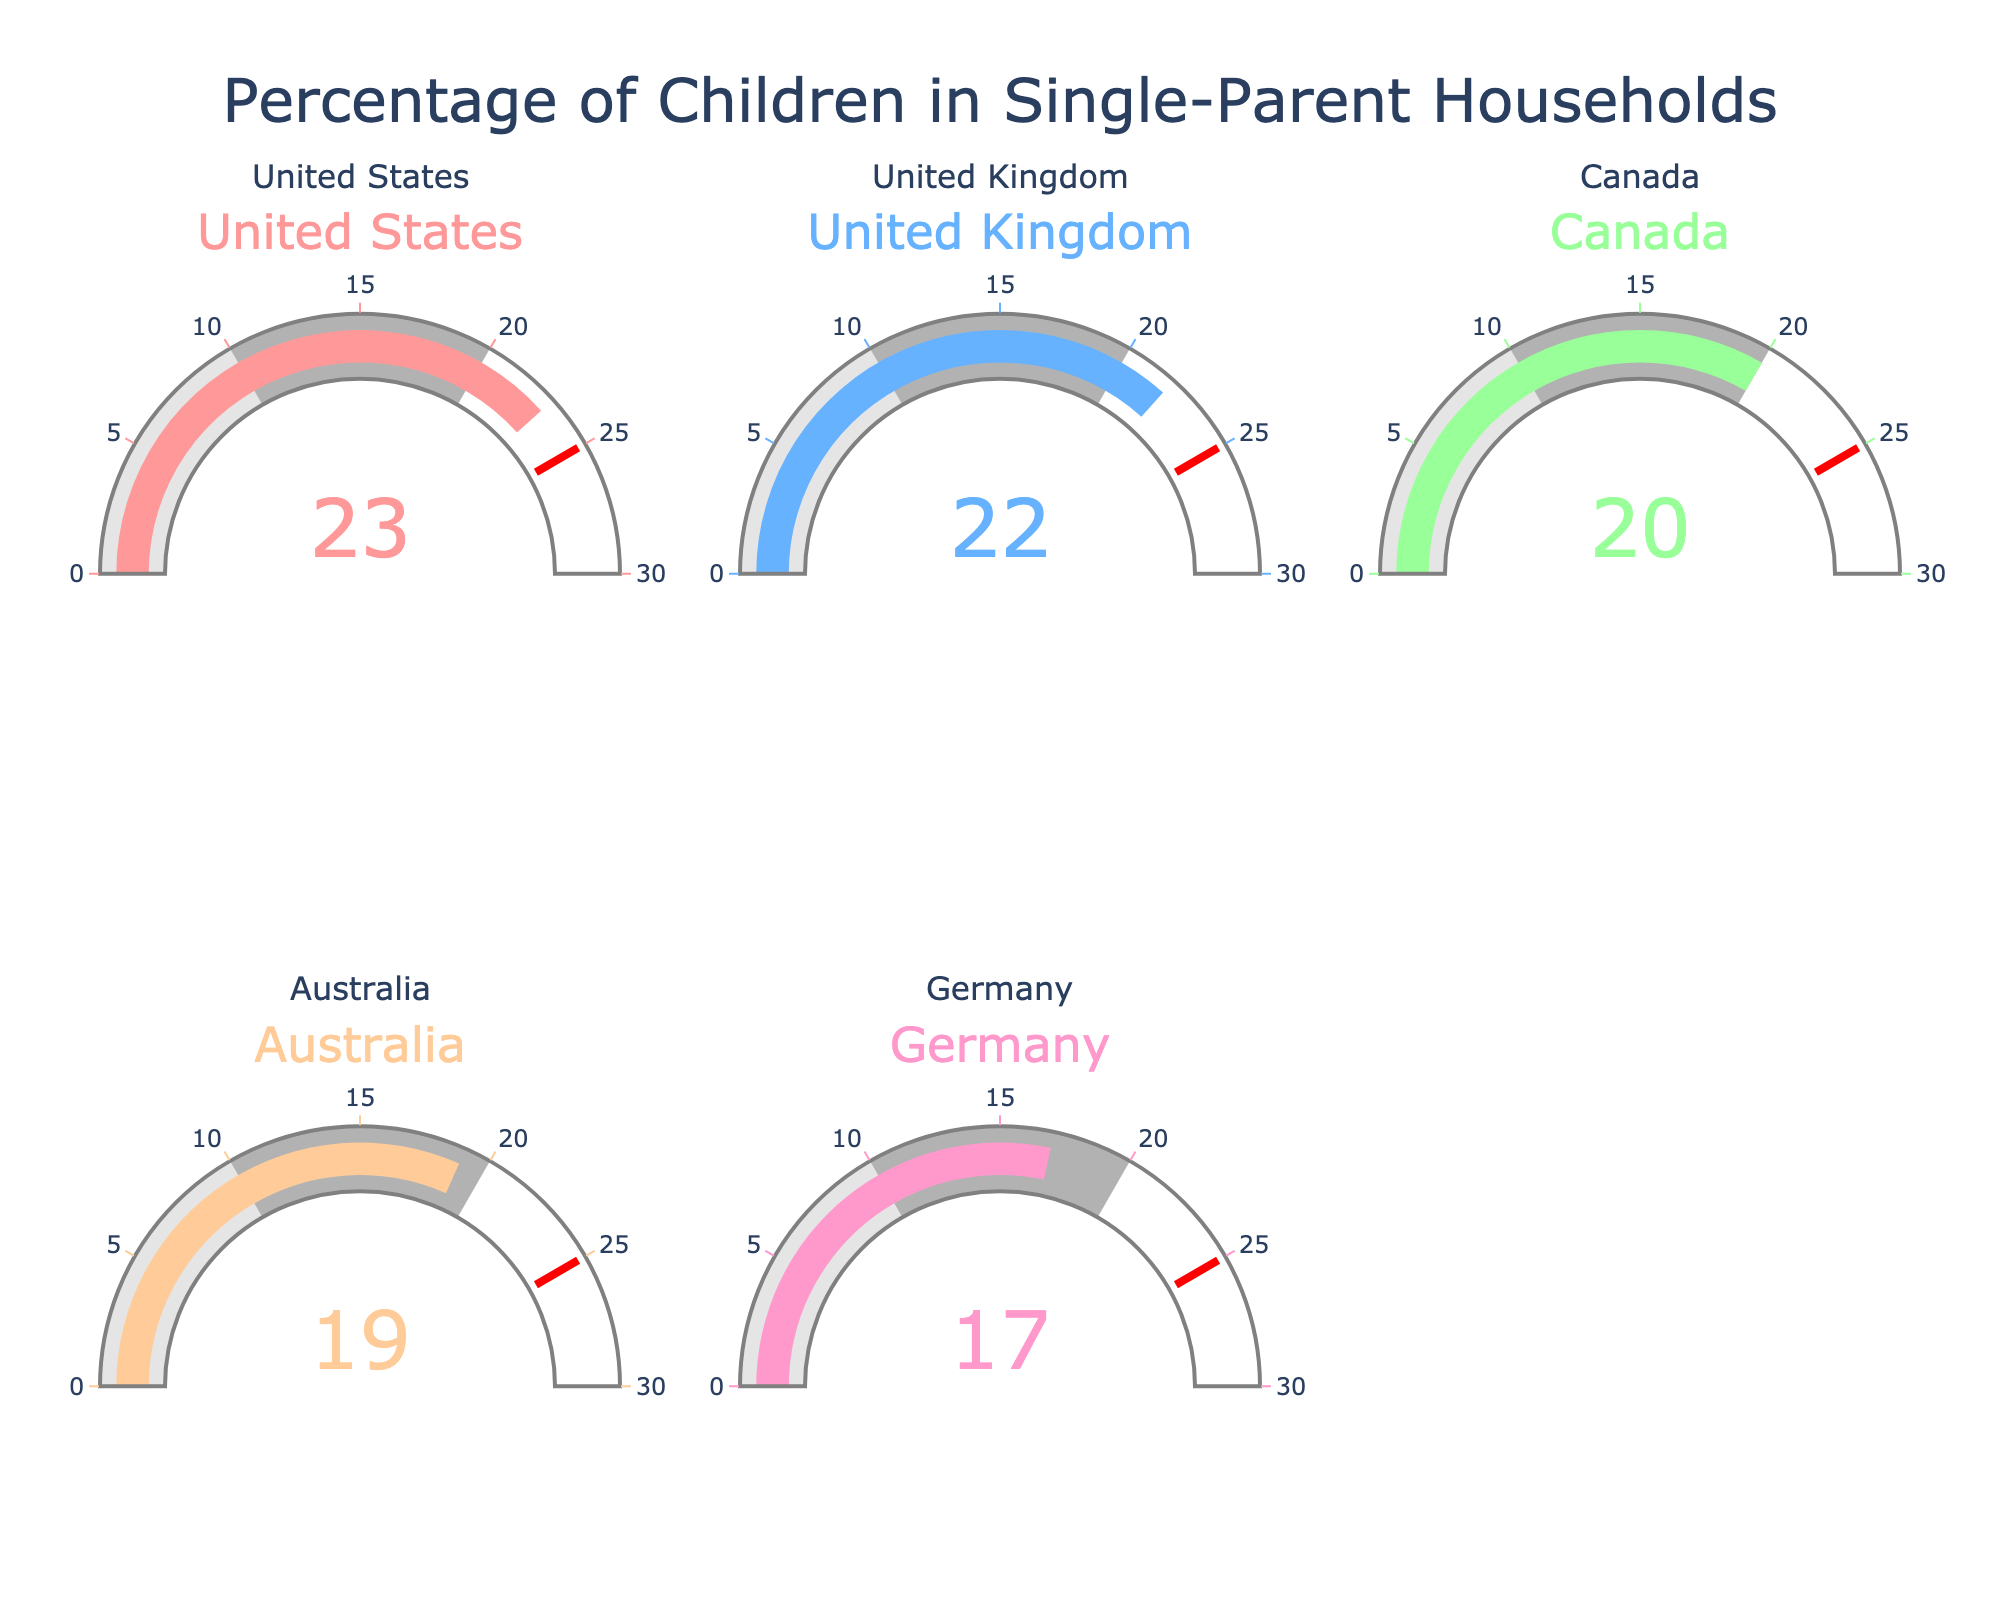What's the title of the figure? The title is displayed at the top center of the figure and reads "Percentage of Children in Single-Parent Households".
Answer: Percentage of Children in Single-Parent Households Which country has the highest percentage of children in single-parent households? By scanning the gauge charts, the highest value is 23%, which belongs to the United States.
Answer: United States How many countries are plotted in the figure? By counting the number of gauge charts in the figure, there are 5 countries represented.
Answer: 5 What is the percentage of children in single-parent households in Germany? Locate the gauge for Germany, which shows that the percentage is 17%.
Answer: 17% Which two countries have the closest percentages of children in single-parent households? By checking the values, the United States has 23% and the United Kingdom has 22%, making their percentages the closest.
Answer: United States and United Kingdom What is the average percentage of children in single-parent households across all countries? Sum the percentages (23 + 22 + 20 + 19 + 17) = 101, and then divide by the number of countries (5). So, the average is 101 / 5 = 20.2%.
Answer: 20.2% What is the relative difference in percentage between the country with the highest and the country with the lowest values? The highest value is 23% (United States) and the lowest is 17% (Germany). The difference is 23% - 17% = 6%.
Answer: 6% Are there any countries with a percentage of children in single-parent households above 20%? By examining the figures, we see the United States (23%), the United Kingdom (22%), and Canada (20%) all have percentages above 20%.
Answer: Yes What is the threshold value indicated on the gauges, and what color is used for it? The threshold value is set at 25%, and it is indicated with a red line on the gauge charts.
Answer: 25% and red Which country has the most similar percentage to Australia? Australia's percentage is 19%, which is closest to Canada's 20% when comparing the values of all countries.
Answer: Canada 